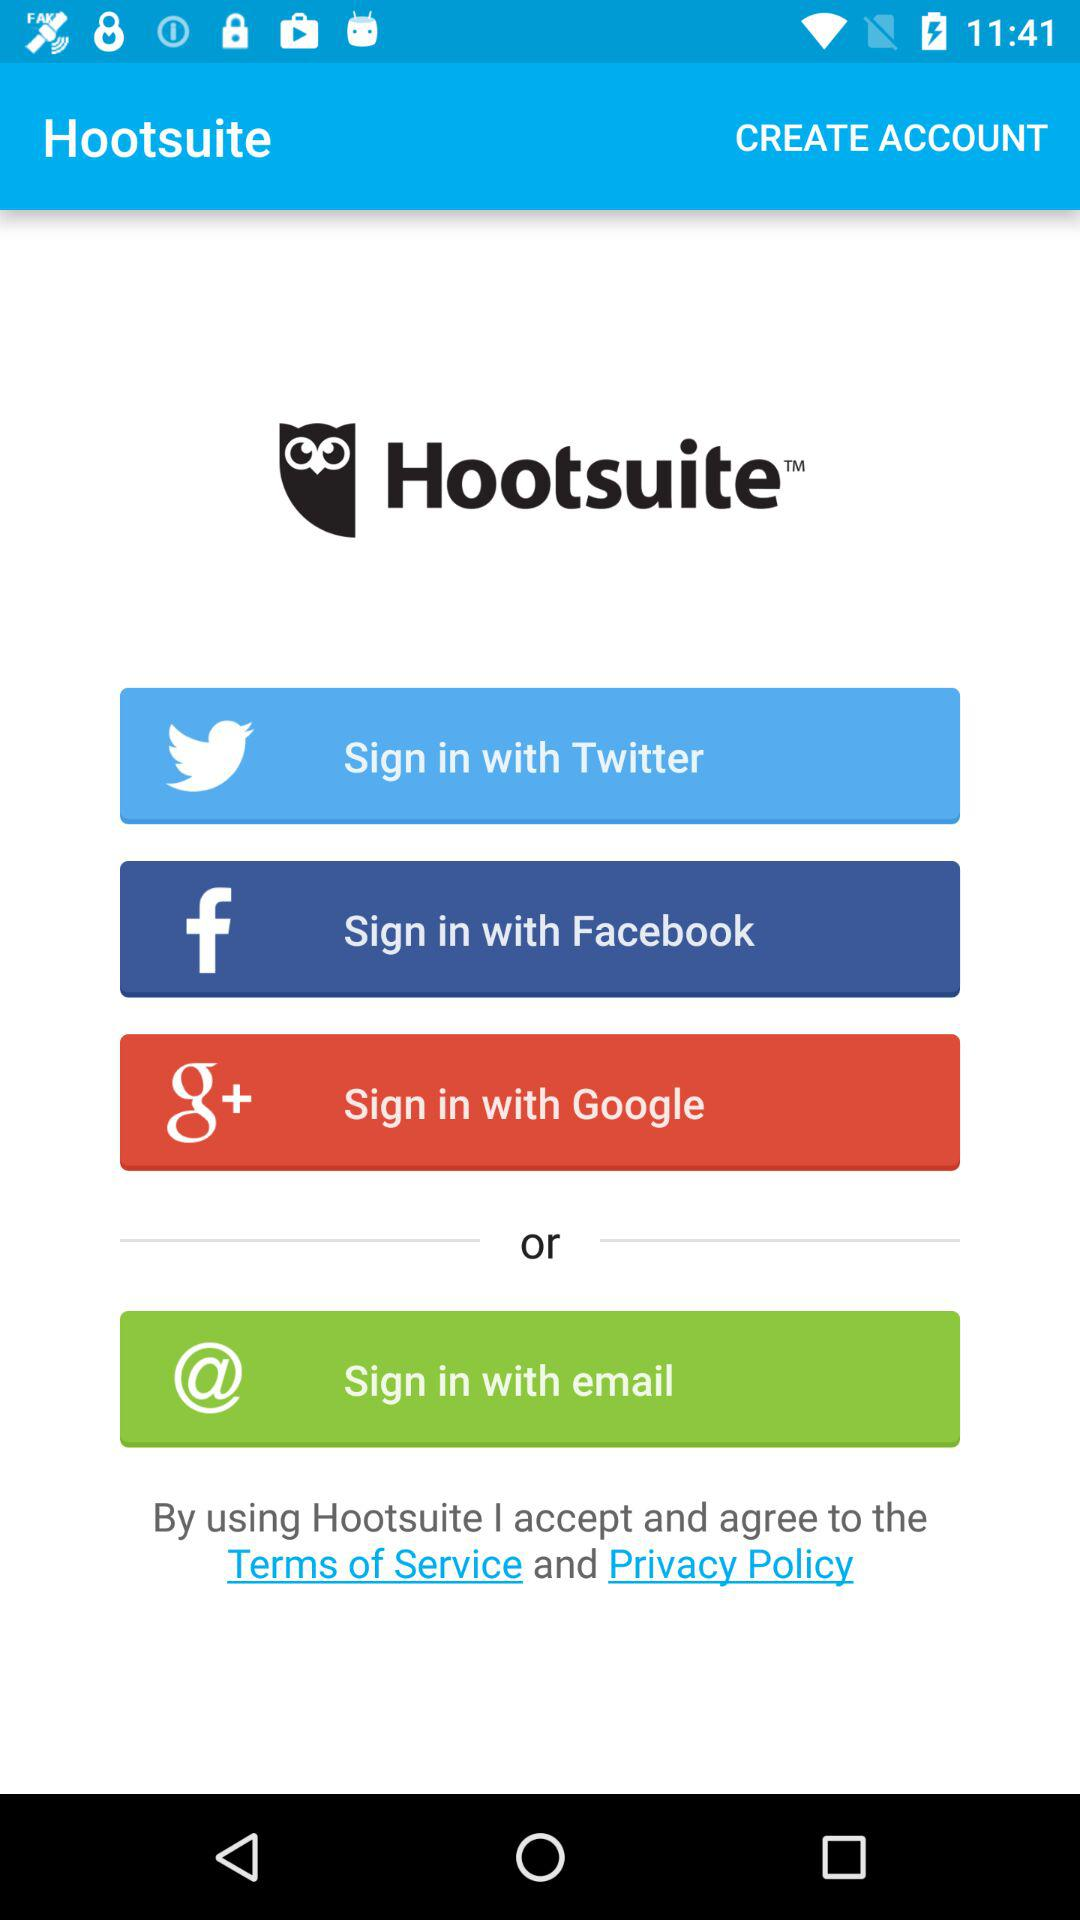What applications are available for signing into a profile? The available applications for signing into a profile are "Twitter", "Facebook" and "Google". 